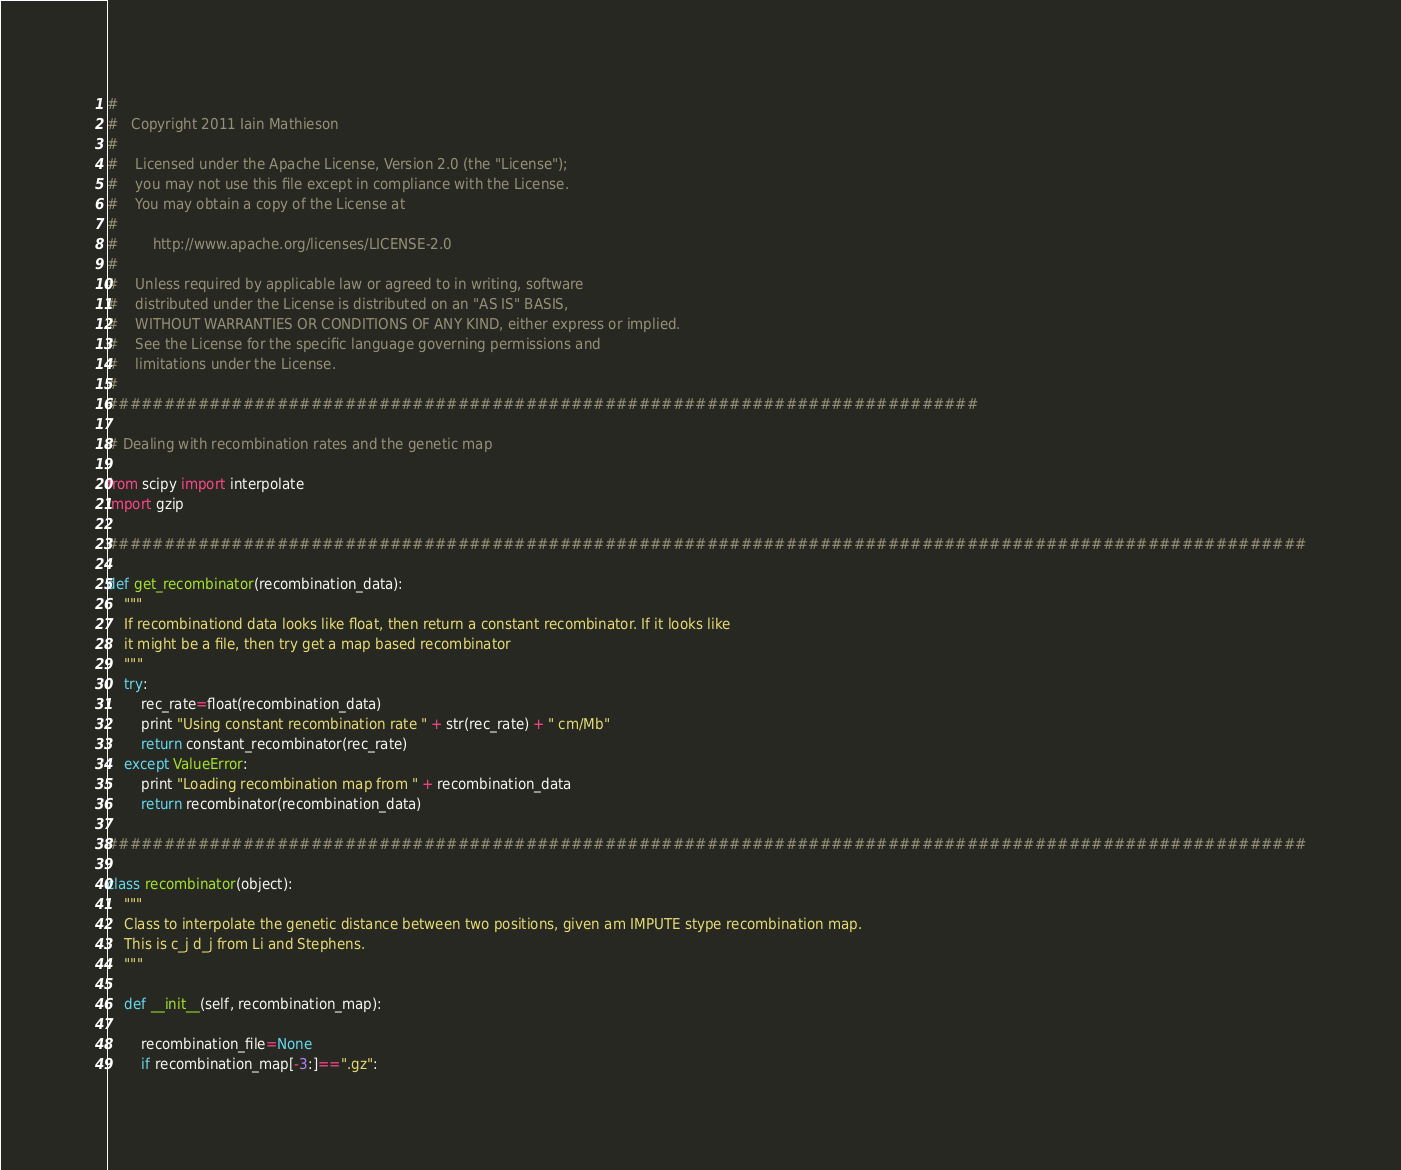Convert code to text. <code><loc_0><loc_0><loc_500><loc_500><_Python_>#
#   Copyright 2011 Iain Mathieson
#
#    Licensed under the Apache License, Version 2.0 (the "License");
#    you may not use this file except in compliance with the License.
#    You may obtain a copy of the License at
#
#        http://www.apache.org/licenses/LICENSE-2.0
#
#    Unless required by applicable law or agreed to in writing, software
#    distributed under the License is distributed on an "AS IS" BASIS,
#    WITHOUT WARRANTIES OR CONDITIONS OF ANY KIND, either express or implied.
#    See the License for the specific language governing permissions and
#    limitations under the License.
#
#############################################################################

# Dealing with recombination rates and the genetic map

from scipy import interpolate
import gzip

##########################################################################################################

def get_recombinator(recombination_data):
    """
    If recombinationd data looks like float, then return a constant recombinator. If it looks like 
    it might be a file, then try get a map based recombinator
    """
    try:
        rec_rate=float(recombination_data)
        print "Using constant recombination rate " + str(rec_rate) + " cm/Mb"
        return constant_recombinator(rec_rate)
    except ValueError:
        print "Loading recombination map from " + recombination_data
        return recombinator(recombination_data)

##########################################################################################################

class recombinator(object):
    """
    Class to interpolate the genetic distance between two positions, given am IMPUTE stype recombination map.
    This is c_j d_j from Li and Stephens. 
    """
    
    def __init__(self, recombination_map):
        
        recombination_file=None
        if recombination_map[-3:]==".gz":</code> 